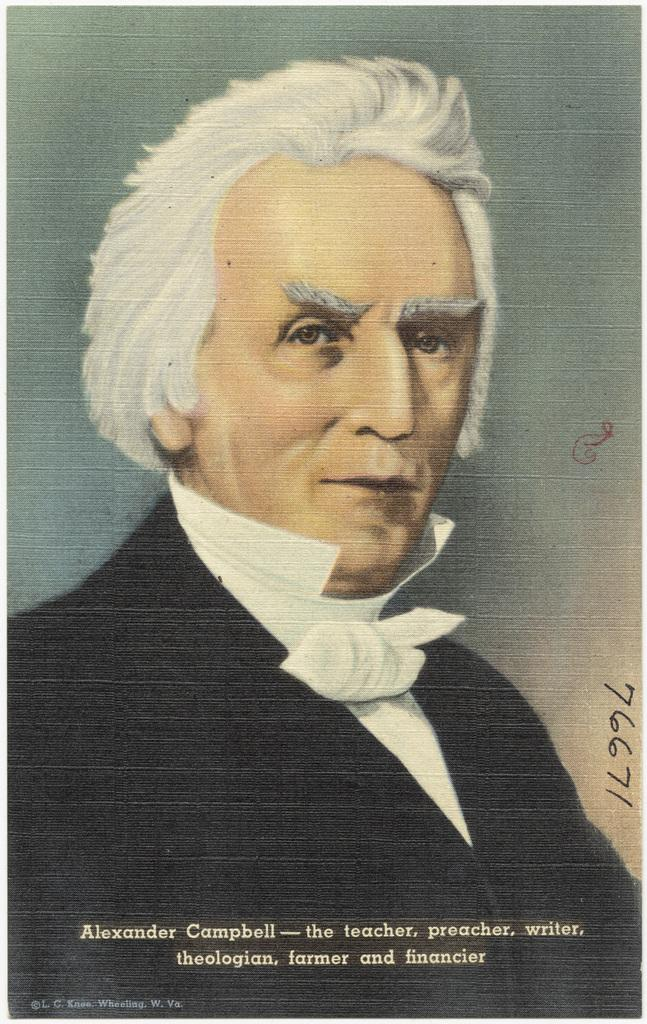What is the main subject of the image? The main subject of the image is a photograph of a man. What else can be seen in the image besides the photograph of the man? There is something written in the image. How many books does the man's sister have in the image? There is no mention of the man's sister or any books in the image. 